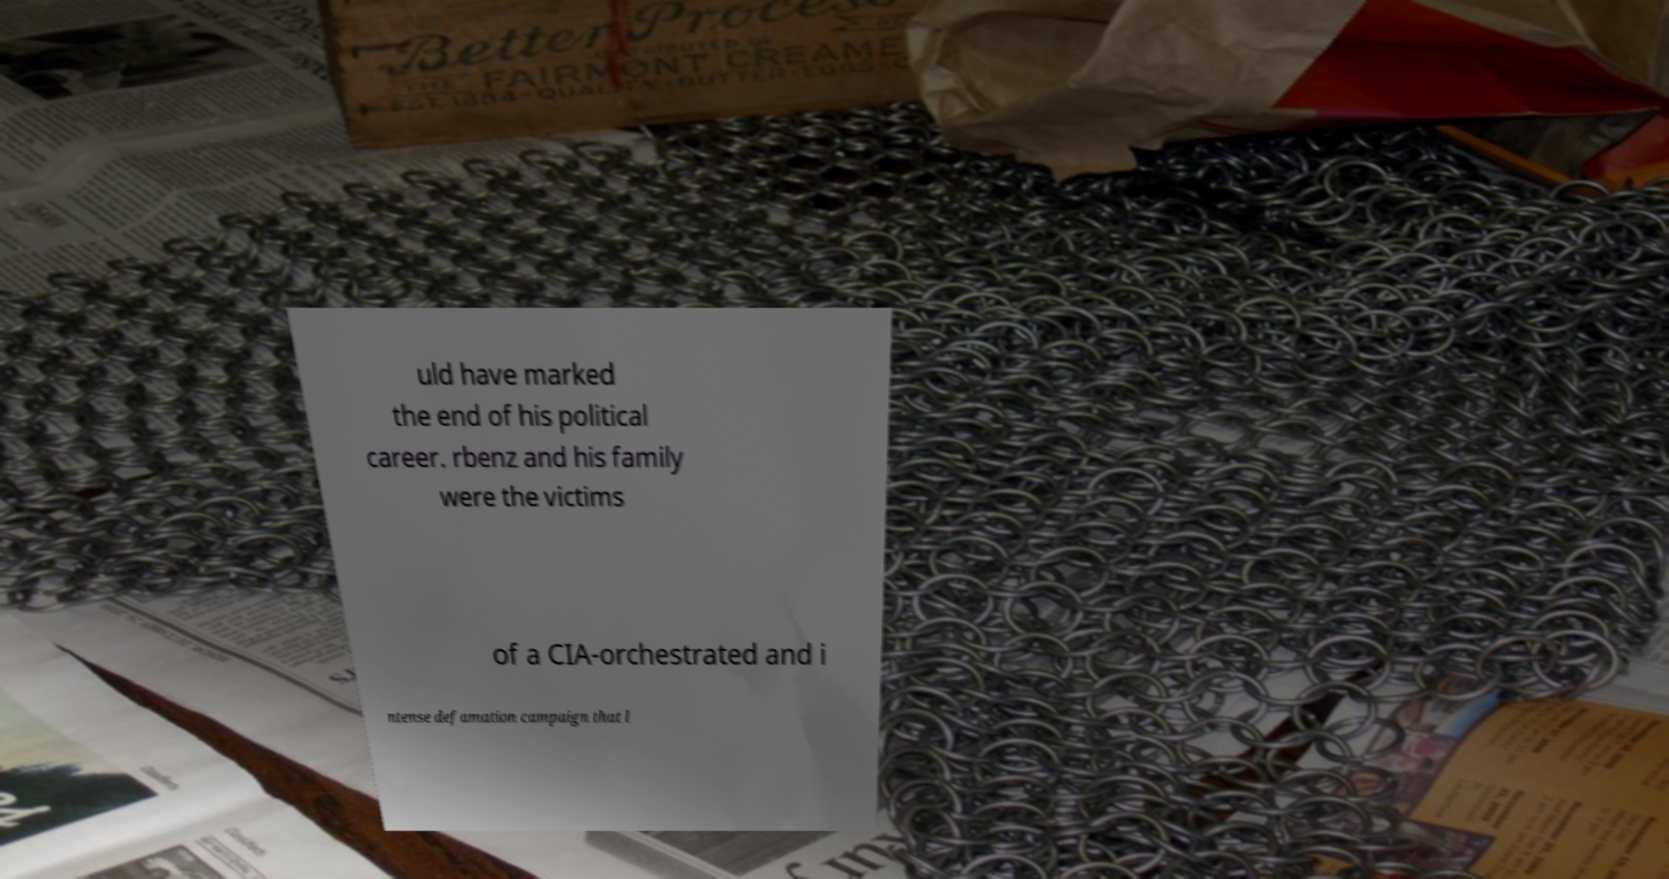Can you accurately transcribe the text from the provided image for me? uld have marked the end of his political career. rbenz and his family were the victims of a CIA-orchestrated and i ntense defamation campaign that l 